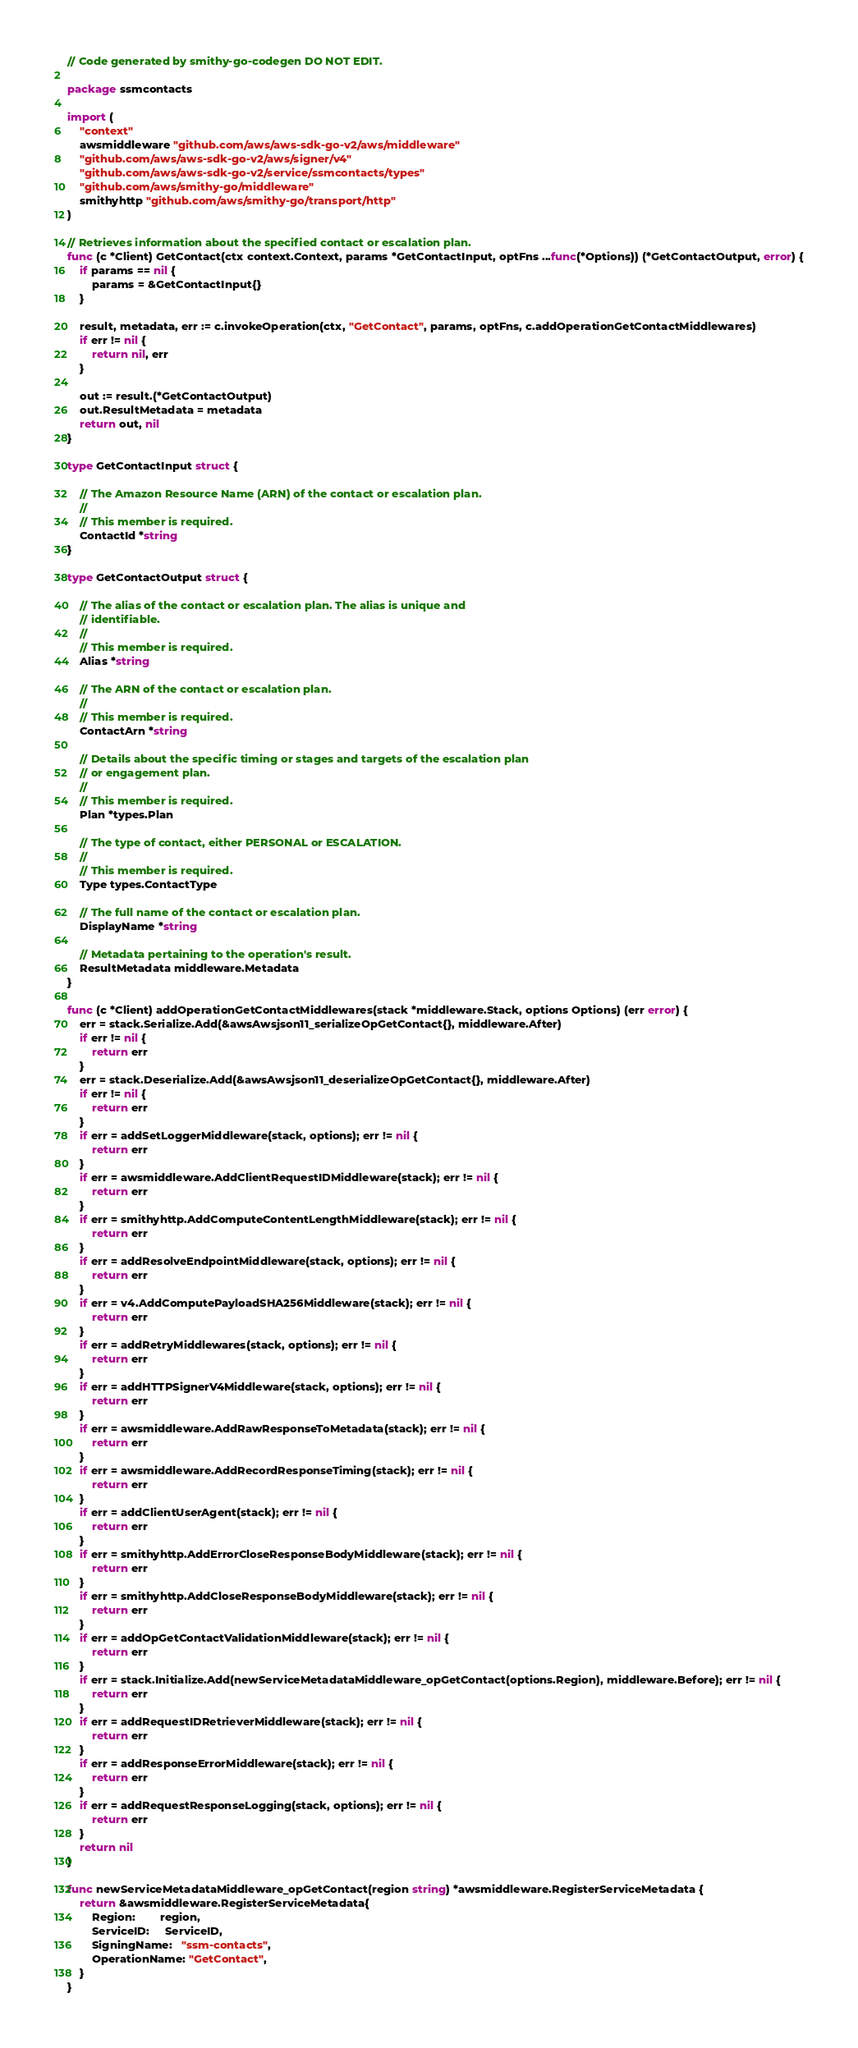<code> <loc_0><loc_0><loc_500><loc_500><_Go_>// Code generated by smithy-go-codegen DO NOT EDIT.

package ssmcontacts

import (
	"context"
	awsmiddleware "github.com/aws/aws-sdk-go-v2/aws/middleware"
	"github.com/aws/aws-sdk-go-v2/aws/signer/v4"
	"github.com/aws/aws-sdk-go-v2/service/ssmcontacts/types"
	"github.com/aws/smithy-go/middleware"
	smithyhttp "github.com/aws/smithy-go/transport/http"
)

// Retrieves information about the specified contact or escalation plan.
func (c *Client) GetContact(ctx context.Context, params *GetContactInput, optFns ...func(*Options)) (*GetContactOutput, error) {
	if params == nil {
		params = &GetContactInput{}
	}

	result, metadata, err := c.invokeOperation(ctx, "GetContact", params, optFns, c.addOperationGetContactMiddlewares)
	if err != nil {
		return nil, err
	}

	out := result.(*GetContactOutput)
	out.ResultMetadata = metadata
	return out, nil
}

type GetContactInput struct {

	// The Amazon Resource Name (ARN) of the contact or escalation plan.
	//
	// This member is required.
	ContactId *string
}

type GetContactOutput struct {

	// The alias of the contact or escalation plan. The alias is unique and
	// identifiable.
	//
	// This member is required.
	Alias *string

	// The ARN of the contact or escalation plan.
	//
	// This member is required.
	ContactArn *string

	// Details about the specific timing or stages and targets of the escalation plan
	// or engagement plan.
	//
	// This member is required.
	Plan *types.Plan

	// The type of contact, either PERSONAL or ESCALATION.
	//
	// This member is required.
	Type types.ContactType

	// The full name of the contact or escalation plan.
	DisplayName *string

	// Metadata pertaining to the operation's result.
	ResultMetadata middleware.Metadata
}

func (c *Client) addOperationGetContactMiddlewares(stack *middleware.Stack, options Options) (err error) {
	err = stack.Serialize.Add(&awsAwsjson11_serializeOpGetContact{}, middleware.After)
	if err != nil {
		return err
	}
	err = stack.Deserialize.Add(&awsAwsjson11_deserializeOpGetContact{}, middleware.After)
	if err != nil {
		return err
	}
	if err = addSetLoggerMiddleware(stack, options); err != nil {
		return err
	}
	if err = awsmiddleware.AddClientRequestIDMiddleware(stack); err != nil {
		return err
	}
	if err = smithyhttp.AddComputeContentLengthMiddleware(stack); err != nil {
		return err
	}
	if err = addResolveEndpointMiddleware(stack, options); err != nil {
		return err
	}
	if err = v4.AddComputePayloadSHA256Middleware(stack); err != nil {
		return err
	}
	if err = addRetryMiddlewares(stack, options); err != nil {
		return err
	}
	if err = addHTTPSignerV4Middleware(stack, options); err != nil {
		return err
	}
	if err = awsmiddleware.AddRawResponseToMetadata(stack); err != nil {
		return err
	}
	if err = awsmiddleware.AddRecordResponseTiming(stack); err != nil {
		return err
	}
	if err = addClientUserAgent(stack); err != nil {
		return err
	}
	if err = smithyhttp.AddErrorCloseResponseBodyMiddleware(stack); err != nil {
		return err
	}
	if err = smithyhttp.AddCloseResponseBodyMiddleware(stack); err != nil {
		return err
	}
	if err = addOpGetContactValidationMiddleware(stack); err != nil {
		return err
	}
	if err = stack.Initialize.Add(newServiceMetadataMiddleware_opGetContact(options.Region), middleware.Before); err != nil {
		return err
	}
	if err = addRequestIDRetrieverMiddleware(stack); err != nil {
		return err
	}
	if err = addResponseErrorMiddleware(stack); err != nil {
		return err
	}
	if err = addRequestResponseLogging(stack, options); err != nil {
		return err
	}
	return nil
}

func newServiceMetadataMiddleware_opGetContact(region string) *awsmiddleware.RegisterServiceMetadata {
	return &awsmiddleware.RegisterServiceMetadata{
		Region:        region,
		ServiceID:     ServiceID,
		SigningName:   "ssm-contacts",
		OperationName: "GetContact",
	}
}
</code> 